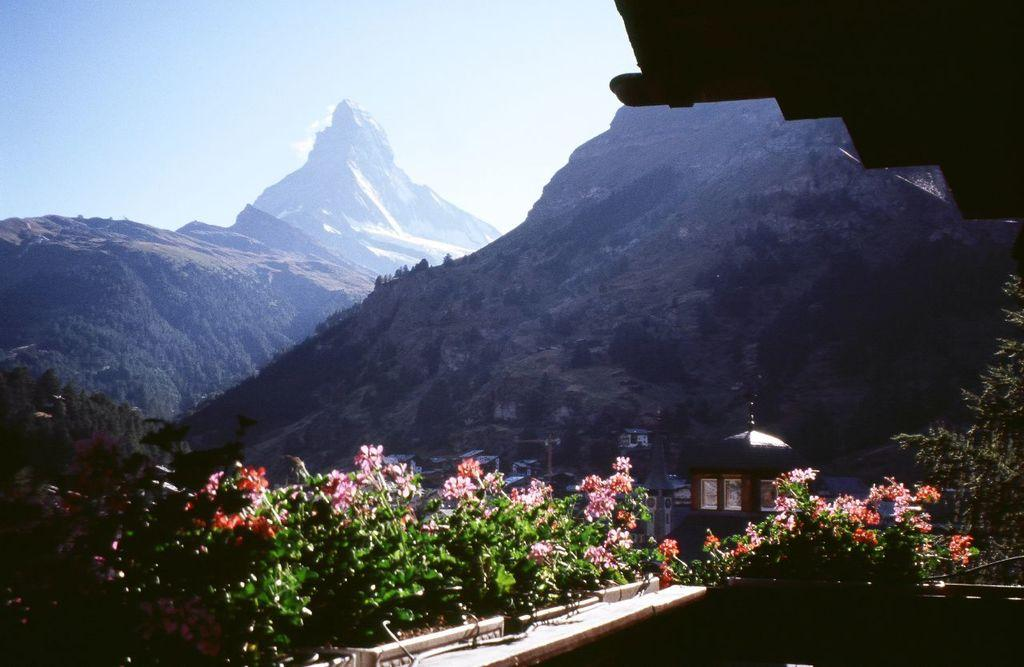What type of natural formation can be seen in the image? There are mountains in the image. What type of vegetation is present in the image? There are trees in the image. What type of man-made structures are visible in the image? There are buildings in the image. What part of the natural environment is visible in the image? The sky is visible in the image. What type of net is being used to catch fish in the image? There is no net present in the image; it features mountains, trees, buildings, and the sky. What type of road can be seen leading up to the mountains in the image? There is no road visible in the image; it only shows mountains, trees, buildings, and the sky. 